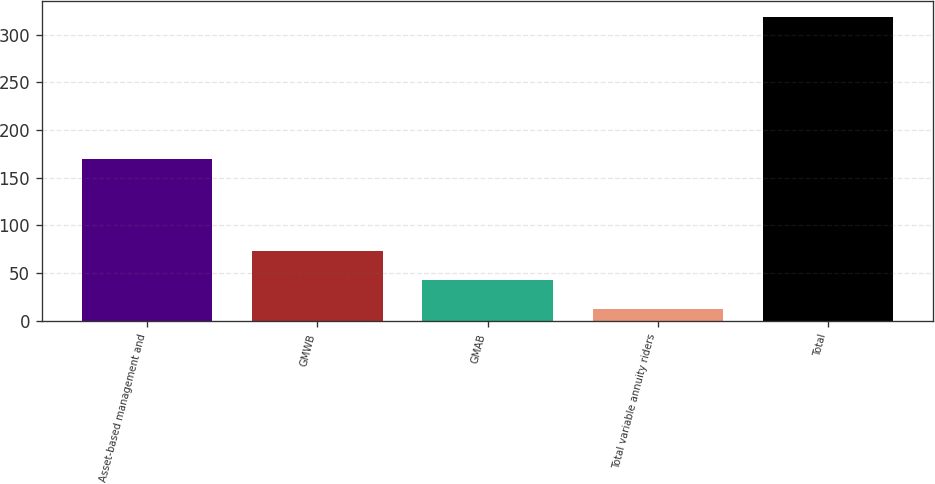<chart> <loc_0><loc_0><loc_500><loc_500><bar_chart><fcel>Asset-based management and<fcel>GMWB<fcel>GMAB<fcel>Total variable annuity riders<fcel>Total<nl><fcel>170<fcel>73.4<fcel>42.7<fcel>12<fcel>319<nl></chart> 